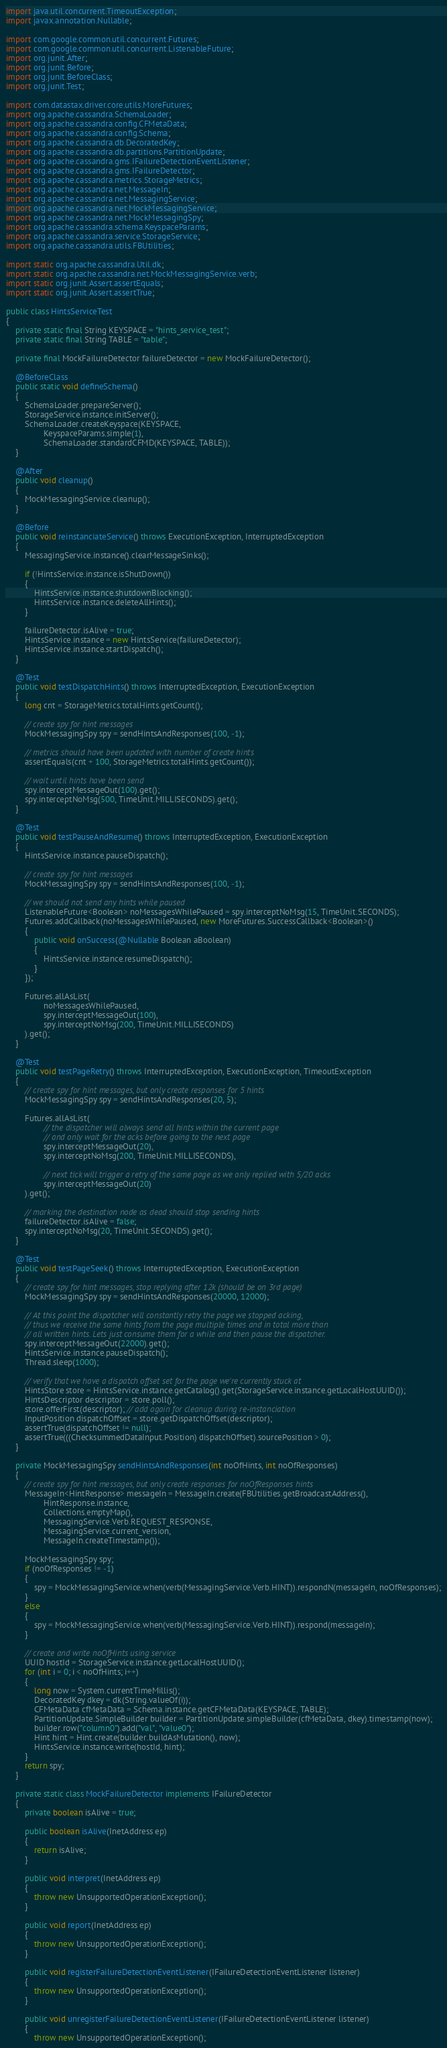Convert code to text. <code><loc_0><loc_0><loc_500><loc_500><_Java_>import java.util.concurrent.TimeoutException;
import javax.annotation.Nullable;

import com.google.common.util.concurrent.Futures;
import com.google.common.util.concurrent.ListenableFuture;
import org.junit.After;
import org.junit.Before;
import org.junit.BeforeClass;
import org.junit.Test;

import com.datastax.driver.core.utils.MoreFutures;
import org.apache.cassandra.SchemaLoader;
import org.apache.cassandra.config.CFMetaData;
import org.apache.cassandra.config.Schema;
import org.apache.cassandra.db.DecoratedKey;
import org.apache.cassandra.db.partitions.PartitionUpdate;
import org.apache.cassandra.gms.IFailureDetectionEventListener;
import org.apache.cassandra.gms.IFailureDetector;
import org.apache.cassandra.metrics.StorageMetrics;
import org.apache.cassandra.net.MessageIn;
import org.apache.cassandra.net.MessagingService;
import org.apache.cassandra.net.MockMessagingService;
import org.apache.cassandra.net.MockMessagingSpy;
import org.apache.cassandra.schema.KeyspaceParams;
import org.apache.cassandra.service.StorageService;
import org.apache.cassandra.utils.FBUtilities;

import static org.apache.cassandra.Util.dk;
import static org.apache.cassandra.net.MockMessagingService.verb;
import static org.junit.Assert.assertEquals;
import static org.junit.Assert.assertTrue;

public class HintsServiceTest
{
    private static final String KEYSPACE = "hints_service_test";
    private static final String TABLE = "table";

    private final MockFailureDetector failureDetector = new MockFailureDetector();

    @BeforeClass
    public static void defineSchema()
    {
        SchemaLoader.prepareServer();
        StorageService.instance.initServer();
        SchemaLoader.createKeyspace(KEYSPACE,
                KeyspaceParams.simple(1),
                SchemaLoader.standardCFMD(KEYSPACE, TABLE));
    }

    @After
    public void cleanup()
    {
        MockMessagingService.cleanup();
    }

    @Before
    public void reinstanciateService() throws ExecutionException, InterruptedException
    {
        MessagingService.instance().clearMessageSinks();

        if (!HintsService.instance.isShutDown())
        {
            HintsService.instance.shutdownBlocking();
            HintsService.instance.deleteAllHints();
        }

        failureDetector.isAlive = true;
        HintsService.instance = new HintsService(failureDetector);
        HintsService.instance.startDispatch();
    }

    @Test
    public void testDispatchHints() throws InterruptedException, ExecutionException
    {
        long cnt = StorageMetrics.totalHints.getCount();

        // create spy for hint messages
        MockMessagingSpy spy = sendHintsAndResponses(100, -1);

        // metrics should have been updated with number of create hints
        assertEquals(cnt + 100, StorageMetrics.totalHints.getCount());

        // wait until hints have been send
        spy.interceptMessageOut(100).get();
        spy.interceptNoMsg(500, TimeUnit.MILLISECONDS).get();
    }

    @Test
    public void testPauseAndResume() throws InterruptedException, ExecutionException
    {
        HintsService.instance.pauseDispatch();

        // create spy for hint messages
        MockMessagingSpy spy = sendHintsAndResponses(100, -1);

        // we should not send any hints while paused
        ListenableFuture<Boolean> noMessagesWhilePaused = spy.interceptNoMsg(15, TimeUnit.SECONDS);
        Futures.addCallback(noMessagesWhilePaused, new MoreFutures.SuccessCallback<Boolean>()
        {
            public void onSuccess(@Nullable Boolean aBoolean)
            {
                HintsService.instance.resumeDispatch();
            }
        });

        Futures.allAsList(
                noMessagesWhilePaused,
                spy.interceptMessageOut(100),
                spy.interceptNoMsg(200, TimeUnit.MILLISECONDS)
        ).get();
    }

    @Test
    public void testPageRetry() throws InterruptedException, ExecutionException, TimeoutException
    {
        // create spy for hint messages, but only create responses for 5 hints
        MockMessagingSpy spy = sendHintsAndResponses(20, 5);

        Futures.allAsList(
                // the dispatcher will always send all hints within the current page
                // and only wait for the acks before going to the next page
                spy.interceptMessageOut(20),
                spy.interceptNoMsg(200, TimeUnit.MILLISECONDS),

                // next tick will trigger a retry of the same page as we only replied with 5/20 acks
                spy.interceptMessageOut(20)
        ).get();

        // marking the destination node as dead should stop sending hints
        failureDetector.isAlive = false;
        spy.interceptNoMsg(20, TimeUnit.SECONDS).get();
    }

    @Test
    public void testPageSeek() throws InterruptedException, ExecutionException
    {
        // create spy for hint messages, stop replying after 12k (should be on 3rd page)
        MockMessagingSpy spy = sendHintsAndResponses(20000, 12000);

        // At this point the dispatcher will constantly retry the page we stopped acking,
        // thus we receive the same hints from the page multiple times and in total more than
        // all written hints. Lets just consume them for a while and then pause the dispatcher.
        spy.interceptMessageOut(22000).get();
        HintsService.instance.pauseDispatch();
        Thread.sleep(1000);

        // verify that we have a dispatch offset set for the page we're currently stuck at
        HintsStore store = HintsService.instance.getCatalog().get(StorageService.instance.getLocalHostUUID());
        HintsDescriptor descriptor = store.poll();
        store.offerFirst(descriptor); // add again for cleanup during re-instanciation
        InputPosition dispatchOffset = store.getDispatchOffset(descriptor);
        assertTrue(dispatchOffset != null);
        assertTrue(((ChecksummedDataInput.Position) dispatchOffset).sourcePosition > 0);
    }

    private MockMessagingSpy sendHintsAndResponses(int noOfHints, int noOfResponses)
    {
        // create spy for hint messages, but only create responses for noOfResponses hints
        MessageIn<HintResponse> messageIn = MessageIn.create(FBUtilities.getBroadcastAddress(),
                HintResponse.instance,
                Collections.emptyMap(),
                MessagingService.Verb.REQUEST_RESPONSE,
                MessagingService.current_version,
                MessageIn.createTimestamp());

        MockMessagingSpy spy;
        if (noOfResponses != -1)
        {
            spy = MockMessagingService.when(verb(MessagingService.Verb.HINT)).respondN(messageIn, noOfResponses);
        }
        else
        {
            spy = MockMessagingService.when(verb(MessagingService.Verb.HINT)).respond(messageIn);
        }

        // create and write noOfHints using service
        UUID hostId = StorageService.instance.getLocalHostUUID();
        for (int i = 0; i < noOfHints; i++)
        {
            long now = System.currentTimeMillis();
            DecoratedKey dkey = dk(String.valueOf(i));
            CFMetaData cfMetaData = Schema.instance.getCFMetaData(KEYSPACE, TABLE);
            PartitionUpdate.SimpleBuilder builder = PartitionUpdate.simpleBuilder(cfMetaData, dkey).timestamp(now);
            builder.row("column0").add("val", "value0");
            Hint hint = Hint.create(builder.buildAsMutation(), now);
            HintsService.instance.write(hostId, hint);
        }
        return spy;
    }

    private static class MockFailureDetector implements IFailureDetector
    {
        private boolean isAlive = true;

        public boolean isAlive(InetAddress ep)
        {
            return isAlive;
        }

        public void interpret(InetAddress ep)
        {
            throw new UnsupportedOperationException();
        }

        public void report(InetAddress ep)
        {
            throw new UnsupportedOperationException();
        }

        public void registerFailureDetectionEventListener(IFailureDetectionEventListener listener)
        {
            throw new UnsupportedOperationException();
        }

        public void unregisterFailureDetectionEventListener(IFailureDetectionEventListener listener)
        {
            throw new UnsupportedOperationException();</code> 